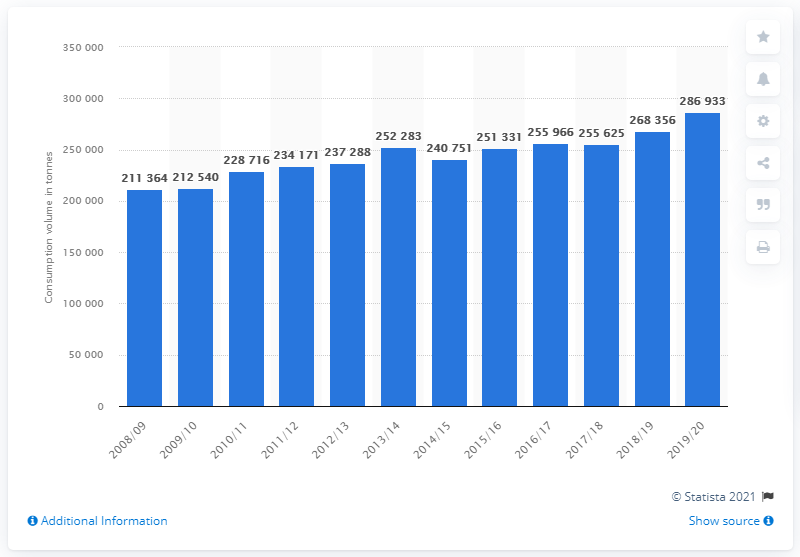Highlight a few significant elements in this photo. In the 2019/2020 season, a total of 286,933 tonnes of tomatoes were consumed in Austria. 